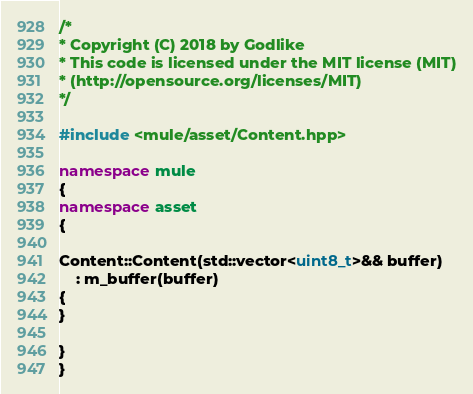Convert code to text. <code><loc_0><loc_0><loc_500><loc_500><_C++_>/*
* Copyright (C) 2018 by Godlike
* This code is licensed under the MIT license (MIT)
* (http://opensource.org/licenses/MIT)
*/

#include <mule/asset/Content.hpp>

namespace mule
{
namespace asset
{

Content::Content(std::vector<uint8_t>&& buffer)
    : m_buffer(buffer)
{
}

}
}

</code> 